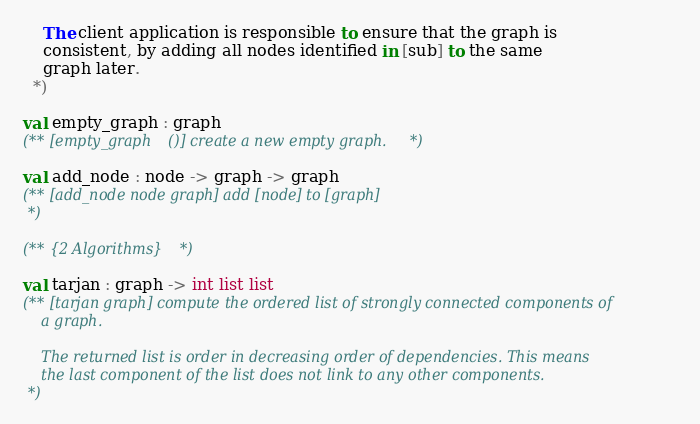<code> <loc_0><loc_0><loc_500><loc_500><_OCaml_>    The client application is responsible to ensure that the graph is
    consistent, by adding all nodes identified in [sub] to the same 
    graph later. 
  *)

val empty_graph : graph 
(** [empty_graph ()] create a new empty graph.*)

val add_node : node -> graph -> graph 
(** [add_node node graph] add [node] to [graph] 
 *)

(** {2 Algorithms} *)

val tarjan : graph -> int list list  
(** [tarjan graph] compute the ordered list of strongly connected components of
    a graph. 

    The returned list is order in decreasing order of dependencies. This means
    the last component of the list does not link to any other components. 
 *)
</code> 